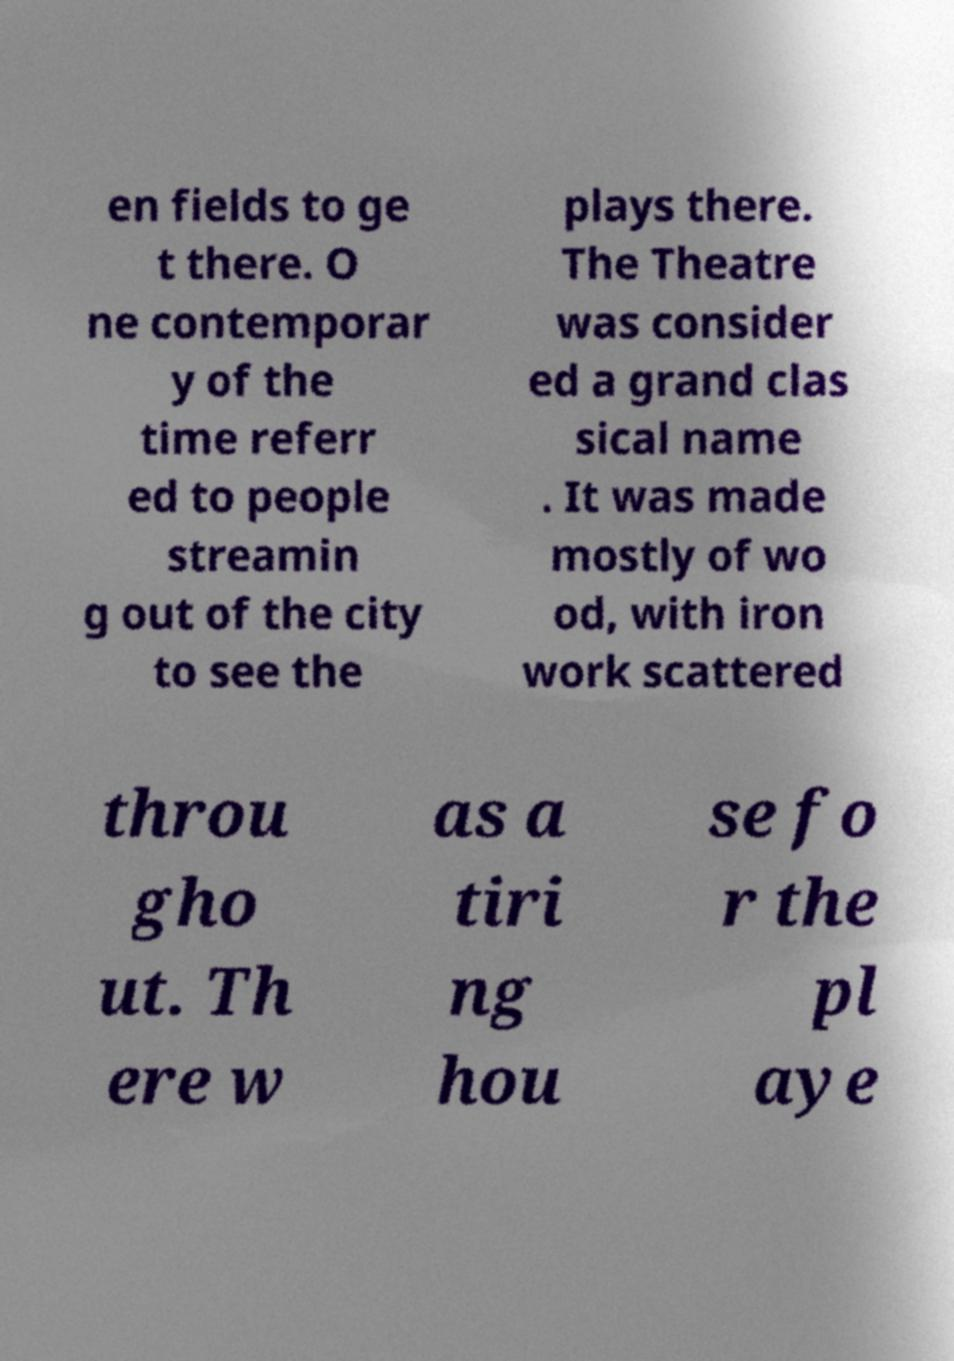Can you read and provide the text displayed in the image?This photo seems to have some interesting text. Can you extract and type it out for me? en fields to ge t there. O ne contemporar y of the time referr ed to people streamin g out of the city to see the plays there. The Theatre was consider ed a grand clas sical name . It was made mostly of wo od, with iron work scattered throu gho ut. Th ere w as a tiri ng hou se fo r the pl aye 